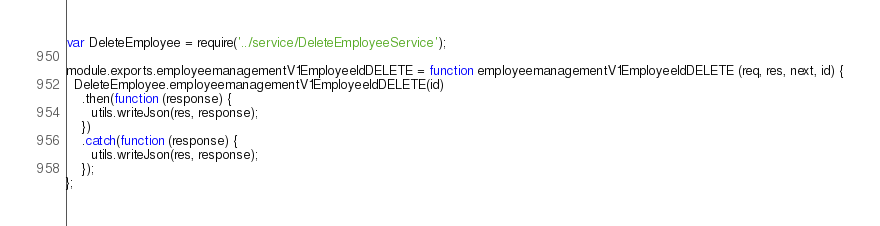Convert code to text. <code><loc_0><loc_0><loc_500><loc_500><_JavaScript_>var DeleteEmployee = require('../service/DeleteEmployeeService');

module.exports.employeemanagementV1EmployeeIdDELETE = function employeemanagementV1EmployeeIdDELETE (req, res, next, id) {
  DeleteEmployee.employeemanagementV1EmployeeIdDELETE(id)
    .then(function (response) {
      utils.writeJson(res, response);
    })
    .catch(function (response) {
      utils.writeJson(res, response);
    });
};
</code> 